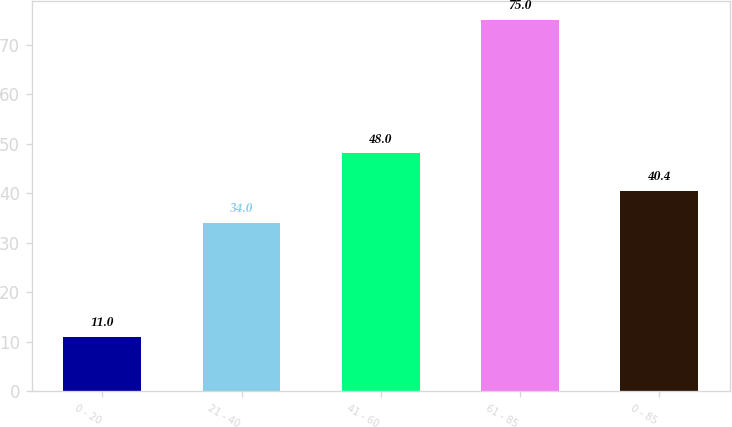<chart> <loc_0><loc_0><loc_500><loc_500><bar_chart><fcel>0 - 20<fcel>21 - 40<fcel>41 - 60<fcel>61 - 85<fcel>0 - 85<nl><fcel>11<fcel>34<fcel>48<fcel>75<fcel>40.4<nl></chart> 